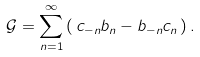Convert formula to latex. <formula><loc_0><loc_0><loc_500><loc_500>\mathcal { G } = \sum _ { n = 1 } ^ { \infty } \left ( \, c _ { - n } b _ { n } - b _ { - n } c _ { n } \, \right ) .</formula> 